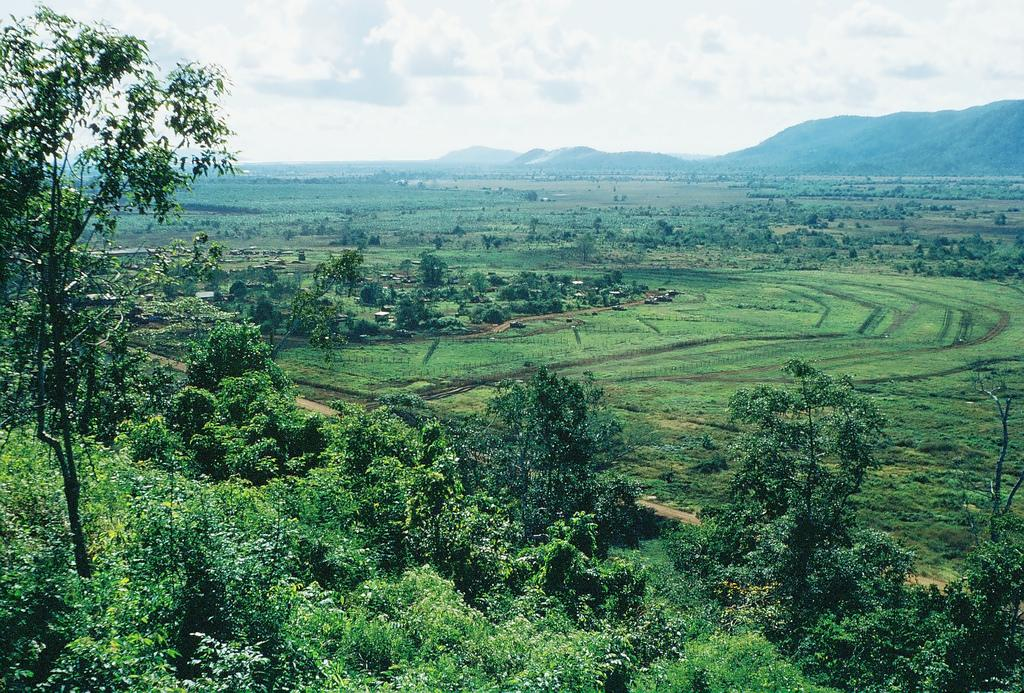What type of natural environment is depicted in the image? The image contains trees, fields, and hills, which are all elements of a natural environment. Can you describe the terrain in the image? The terrain in the image includes fields and hills. What is the condition of the sky in the image? The sky is cloudy in the image. What grade did the bird receive on its recent test in the image? There is no bird or test present in the image, so it is not possible to determine a grade. 